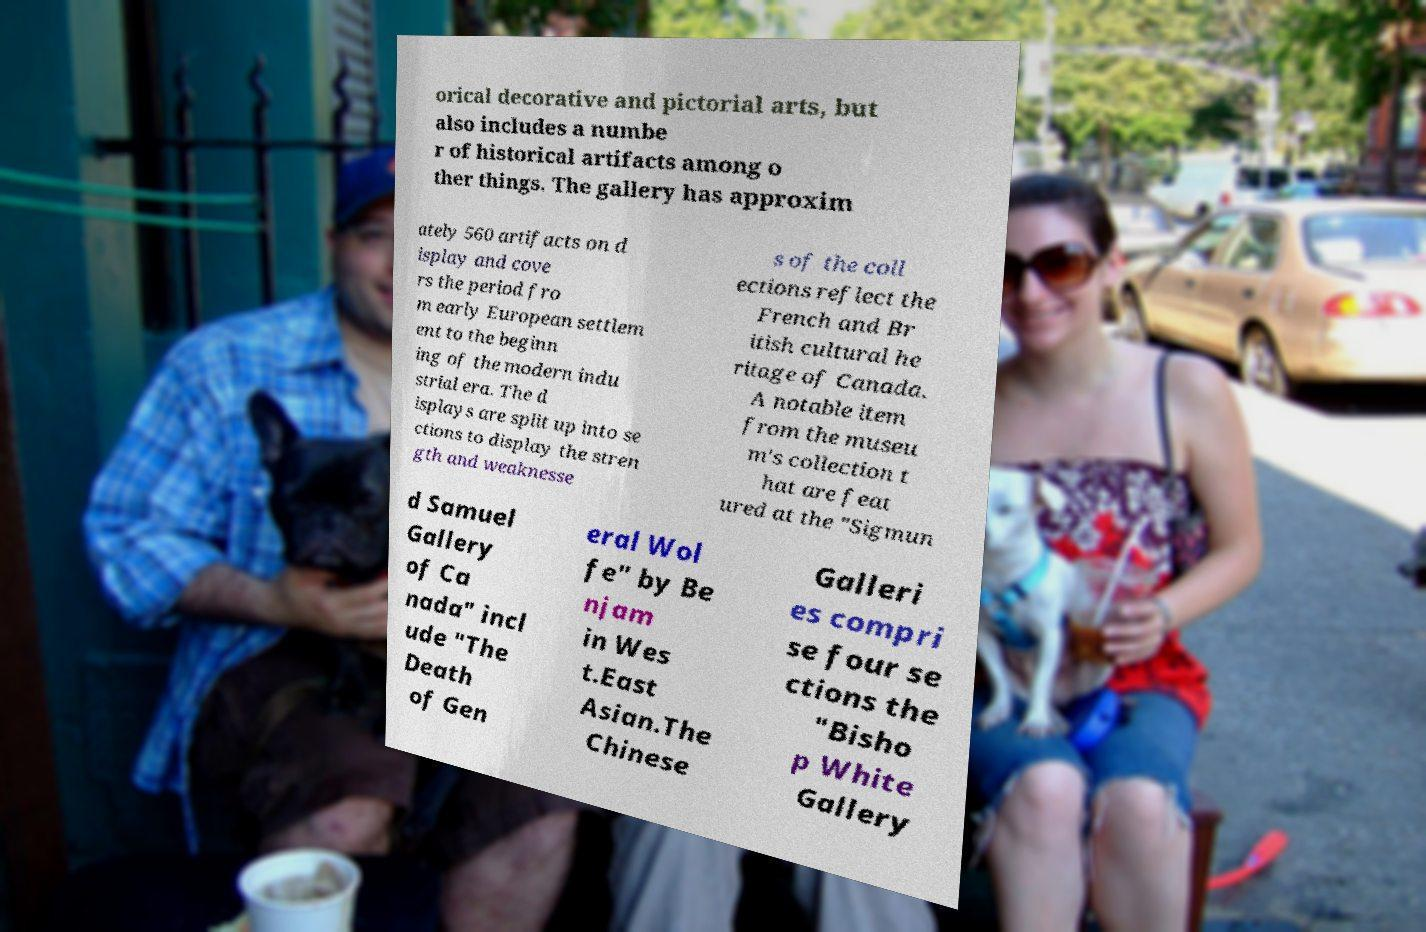I need the written content from this picture converted into text. Can you do that? orical decorative and pictorial arts, but also includes a numbe r of historical artifacts among o ther things. The gallery has approxim ately 560 artifacts on d isplay and cove rs the period fro m early European settlem ent to the beginn ing of the modern indu strial era. The d isplays are split up into se ctions to display the stren gth and weaknesse s of the coll ections reflect the French and Br itish cultural he ritage of Canada. A notable item from the museu m's collection t hat are feat ured at the "Sigmun d Samuel Gallery of Ca nada" incl ude "The Death of Gen eral Wol fe" by Be njam in Wes t.East Asian.The Chinese Galleri es compri se four se ctions the "Bisho p White Gallery 